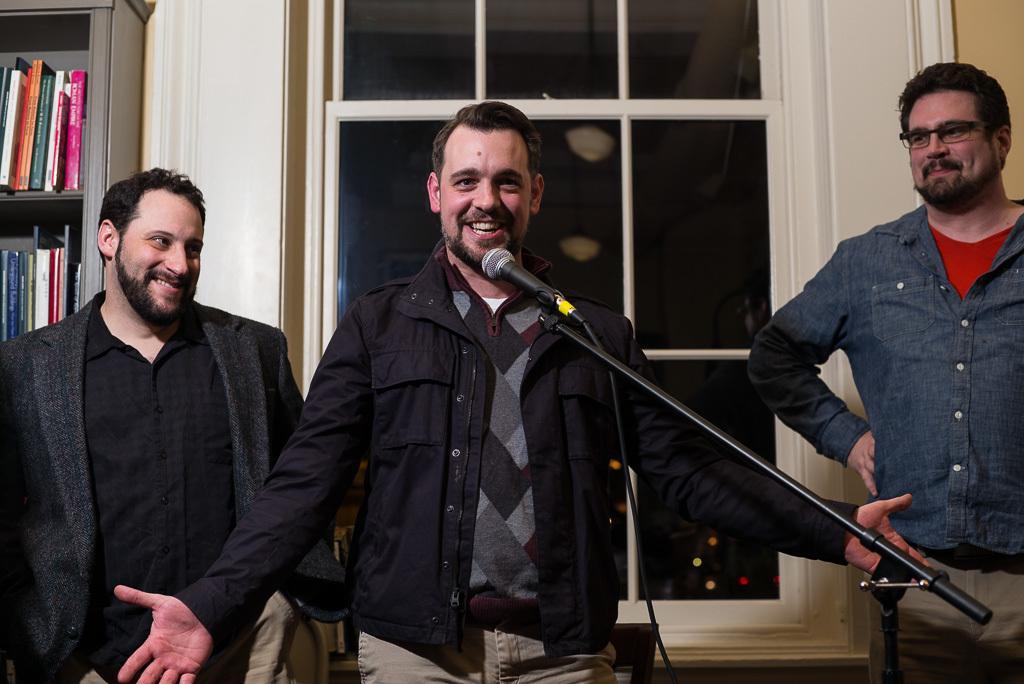In one or two sentences, can you explain what this image depicts? In this image we can see three people. Person on the right is wearing specs. There is a mic with mic stand. In the back there is a window. On the left side there is a cupboard with books. 